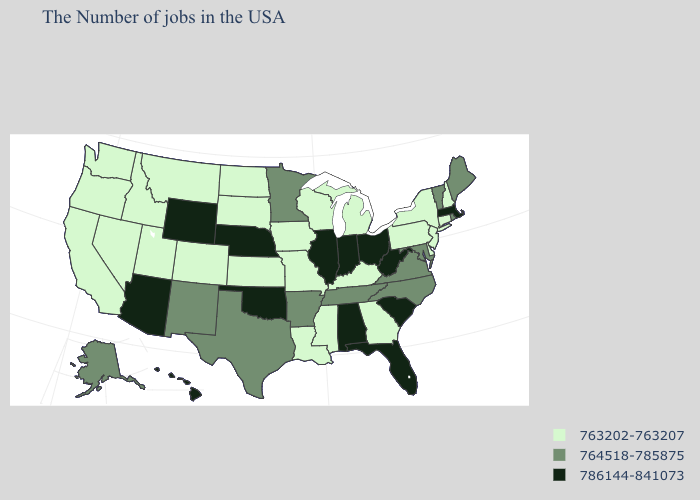What is the value of Kansas?
Answer briefly. 763202-763207. Name the states that have a value in the range 786144-841073?
Give a very brief answer. Massachusetts, South Carolina, West Virginia, Ohio, Florida, Indiana, Alabama, Illinois, Nebraska, Oklahoma, Wyoming, Arizona, Hawaii. Does Wyoming have the highest value in the USA?
Answer briefly. Yes. Name the states that have a value in the range 786144-841073?
Keep it brief. Massachusetts, South Carolina, West Virginia, Ohio, Florida, Indiana, Alabama, Illinois, Nebraska, Oklahoma, Wyoming, Arizona, Hawaii. What is the value of Illinois?
Quick response, please. 786144-841073. Among the states that border Indiana , which have the lowest value?
Answer briefly. Michigan, Kentucky. Among the states that border Maryland , which have the lowest value?
Keep it brief. Delaware, Pennsylvania. Does the first symbol in the legend represent the smallest category?
Give a very brief answer. Yes. Name the states that have a value in the range 763202-763207?
Answer briefly. New Hampshire, Connecticut, New York, New Jersey, Delaware, Pennsylvania, Georgia, Michigan, Kentucky, Wisconsin, Mississippi, Louisiana, Missouri, Iowa, Kansas, South Dakota, North Dakota, Colorado, Utah, Montana, Idaho, Nevada, California, Washington, Oregon. Name the states that have a value in the range 786144-841073?
Write a very short answer. Massachusetts, South Carolina, West Virginia, Ohio, Florida, Indiana, Alabama, Illinois, Nebraska, Oklahoma, Wyoming, Arizona, Hawaii. What is the value of Delaware?
Answer briefly. 763202-763207. Name the states that have a value in the range 763202-763207?
Give a very brief answer. New Hampshire, Connecticut, New York, New Jersey, Delaware, Pennsylvania, Georgia, Michigan, Kentucky, Wisconsin, Mississippi, Louisiana, Missouri, Iowa, Kansas, South Dakota, North Dakota, Colorado, Utah, Montana, Idaho, Nevada, California, Washington, Oregon. Name the states that have a value in the range 763202-763207?
Quick response, please. New Hampshire, Connecticut, New York, New Jersey, Delaware, Pennsylvania, Georgia, Michigan, Kentucky, Wisconsin, Mississippi, Louisiana, Missouri, Iowa, Kansas, South Dakota, North Dakota, Colorado, Utah, Montana, Idaho, Nevada, California, Washington, Oregon. Does the map have missing data?
Concise answer only. No. Among the states that border Iowa , which have the highest value?
Keep it brief. Illinois, Nebraska. 